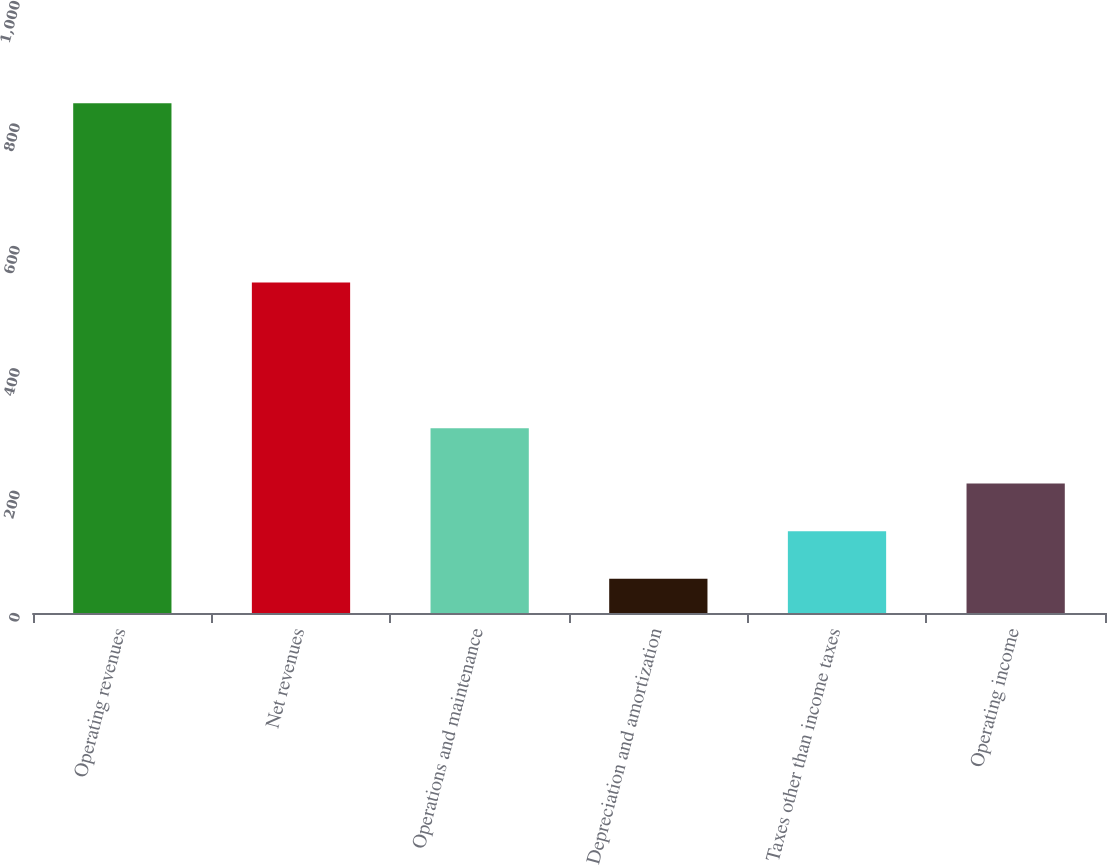Convert chart. <chart><loc_0><loc_0><loc_500><loc_500><bar_chart><fcel>Operating revenues<fcel>Net revenues<fcel>Operations and maintenance<fcel>Depreciation and amortization<fcel>Taxes other than income taxes<fcel>Operating income<nl><fcel>833<fcel>540<fcel>302<fcel>56<fcel>133.7<fcel>211.4<nl></chart> 